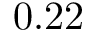Convert formula to latex. <formula><loc_0><loc_0><loc_500><loc_500>0 . 2 2</formula> 